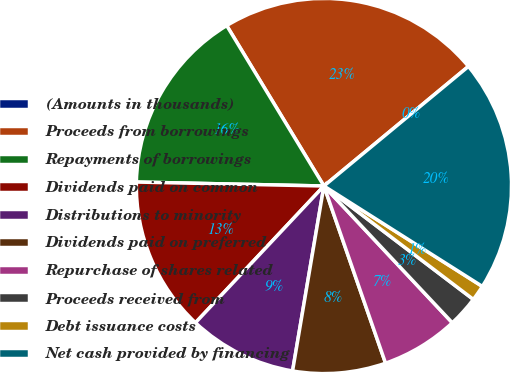<chart> <loc_0><loc_0><loc_500><loc_500><pie_chart><fcel>(Amounts in thousands)<fcel>Proceeds from borrowings<fcel>Repayments of borrowings<fcel>Dividends paid on common<fcel>Distributions to minority<fcel>Dividends paid on preferred<fcel>Repurchase of shares related<fcel>Proceeds received from<fcel>Debt issuance costs<fcel>Net cash provided by financing<nl><fcel>0.01%<fcel>22.66%<fcel>15.99%<fcel>13.33%<fcel>9.33%<fcel>8.0%<fcel>6.67%<fcel>2.67%<fcel>1.34%<fcel>19.99%<nl></chart> 